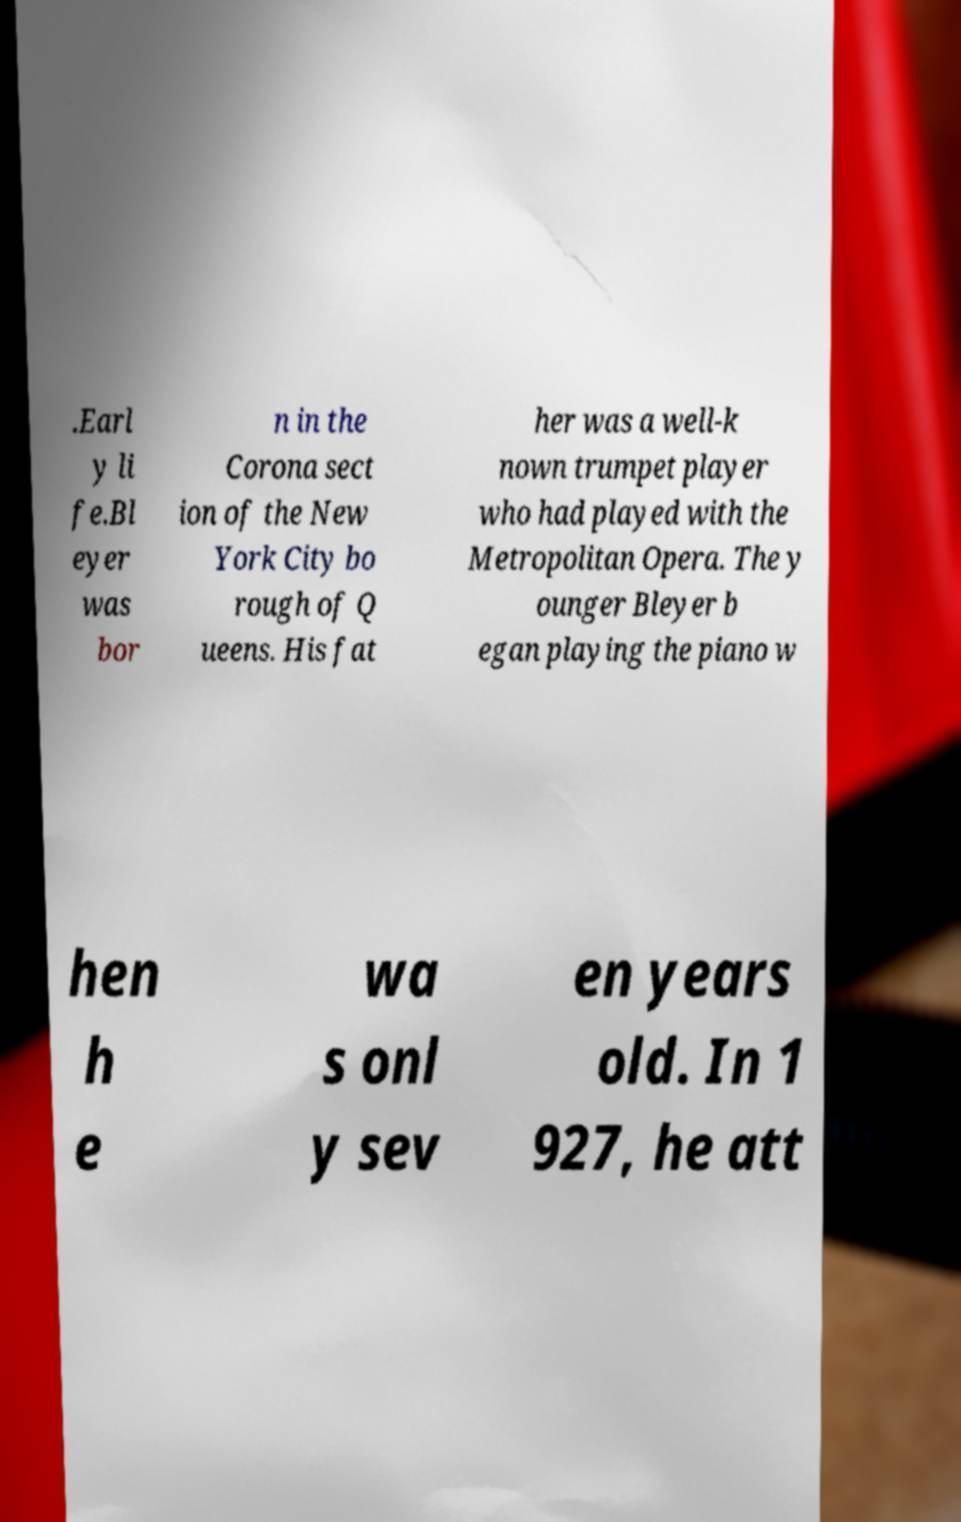Can you read and provide the text displayed in the image?This photo seems to have some interesting text. Can you extract and type it out for me? .Earl y li fe.Bl eyer was bor n in the Corona sect ion of the New York City bo rough of Q ueens. His fat her was a well-k nown trumpet player who had played with the Metropolitan Opera. The y ounger Bleyer b egan playing the piano w hen h e wa s onl y sev en years old. In 1 927, he att 